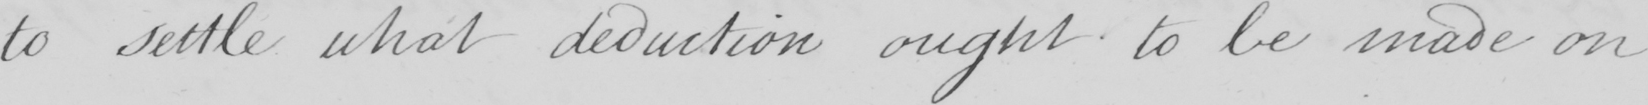Transcribe the text shown in this historical manuscript line. to settle what deduction ought to be made on 